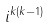Convert formula to latex. <formula><loc_0><loc_0><loc_500><loc_500>i ^ { k ( k - 1 ) }</formula> 